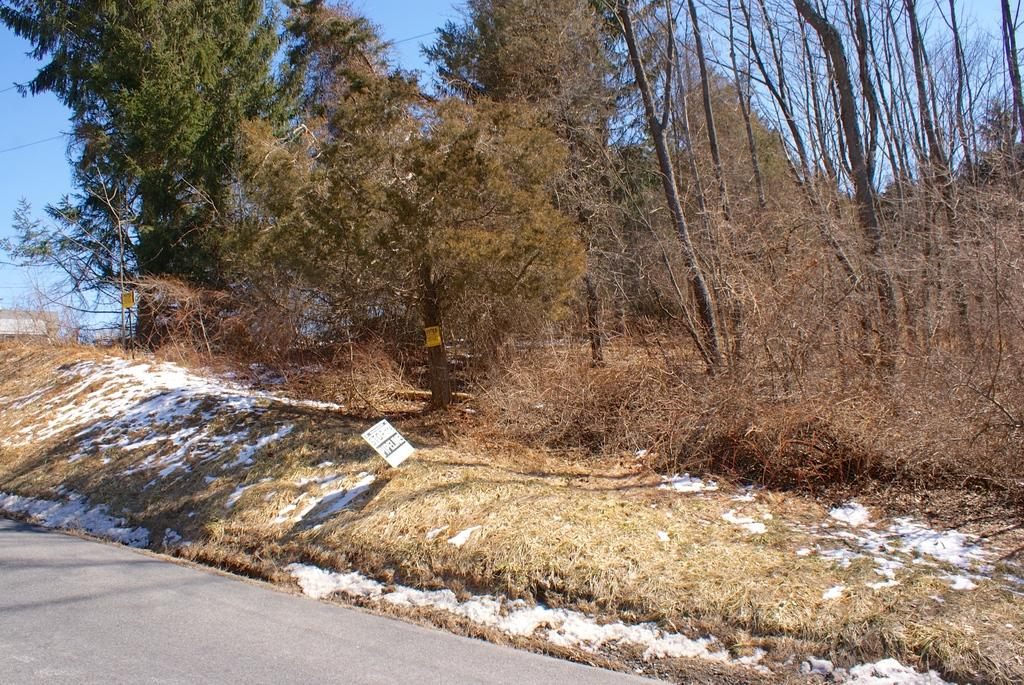What type of vegetation is present in the image? There are trees and grass in the image. What structure can be seen in the image? There is a name board in the image. What other objects are present in the image? There are other objects in the image, but their specific details are not mentioned in the facts. What can be seen in the background of the image? The sky is visible in the background of the image. What type of pathway is visible at the bottom of the image? There is a road at the bottom of the image. Where is the mailbox located in the image? There is no mailbox present in the image. What type of society is depicted in the image? The image does not depict any society; it shows natural elements and a name board. 